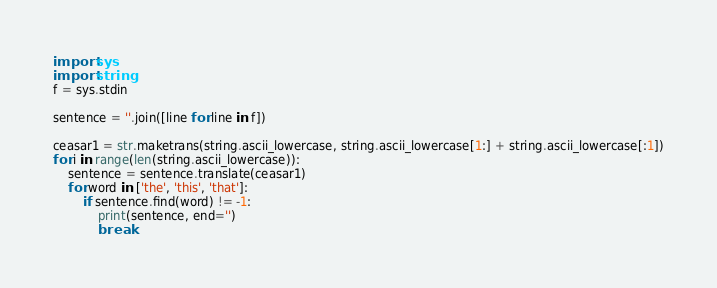Convert code to text. <code><loc_0><loc_0><loc_500><loc_500><_Python_>import sys
import string
f = sys.stdin

sentence = ''.join([line for line in f])

ceasar1 = str.maketrans(string.ascii_lowercase, string.ascii_lowercase[1:] + string.ascii_lowercase[:1])
for i in range(len(string.ascii_lowercase)):
    sentence = sentence.translate(ceasar1)
    for word in ['the', 'this', 'that']:
        if sentence.find(word) != -1:
            print(sentence, end='')
            break</code> 